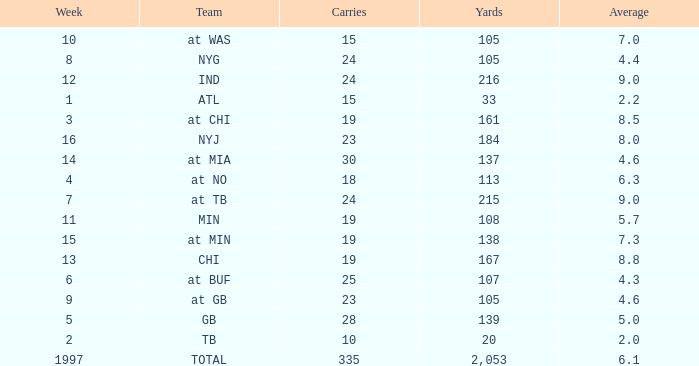Which Team has 19 Carries, and a Week larger than 13? At min. 